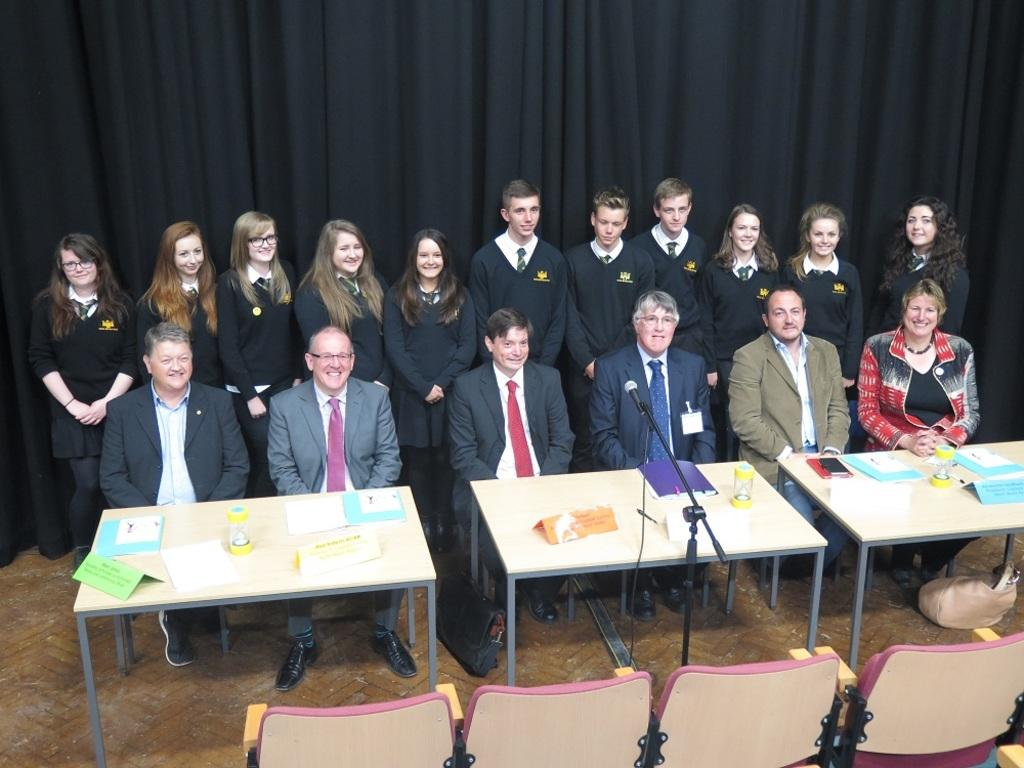What are the people in the image doing? There is a group of people seated in the image, suggesting they might be attending an event or gathering. What are the seated people sitting on? The people are seated on chairs. How many tables are visible in the image? There are three tables in the image. What object is in front of the seated people? There is a microphone in front of the seated people, which might indicate that they are participating in a presentation or discussion. Can you describe the background of the image? There are people standing in the background of the image, and a curtain is visible. What type of mailbox is visible in the image? There is no mailbox present in the image. How many babies are being born in the image? There is no indication of a birth or babies in the image. 